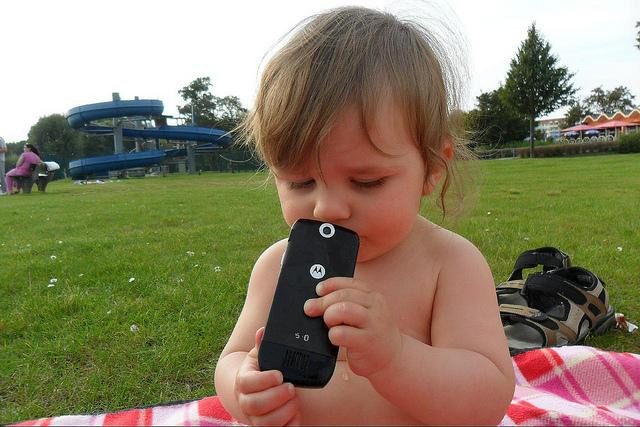What is playing with the phone?

Choices:
A) baby
B) cat
C) bird
D) dog baby 